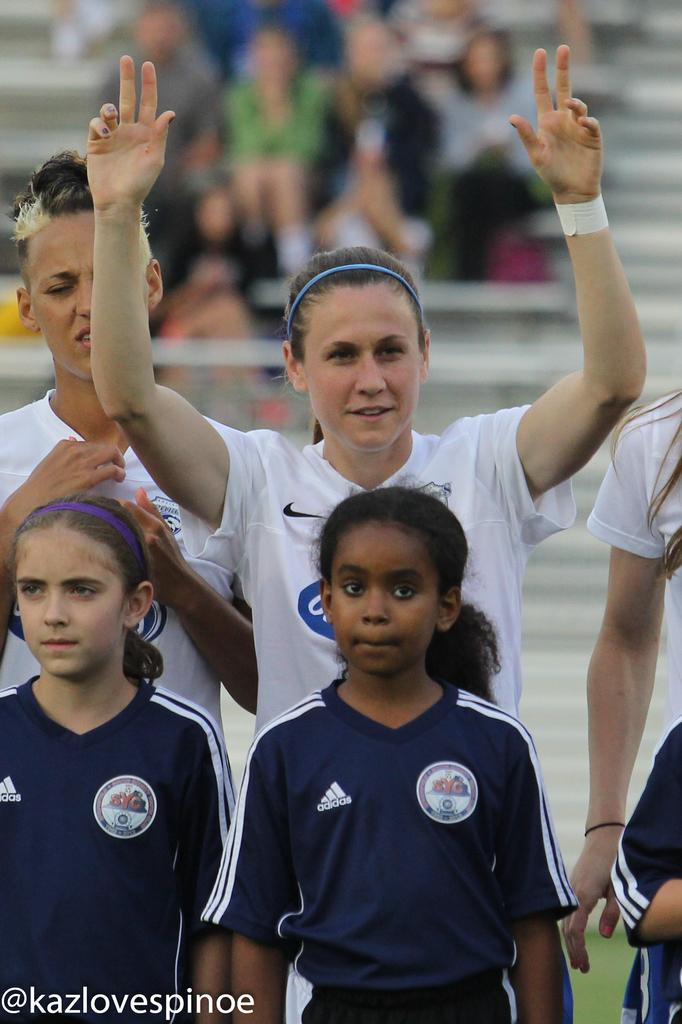Who is present in the image? There are kids and people standing in the image. What can be seen in the background of the image? The background of the image is blurred. Is there any additional information or marking on the image? Yes, there is a watermark on the image. Can you see any zebras in the image? No, there are no zebras present in the image. What type of horn is visible on the head of one of the kids? There is no horn visible on the head of any of the kids in the image. 